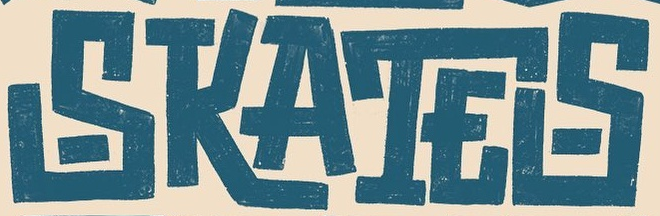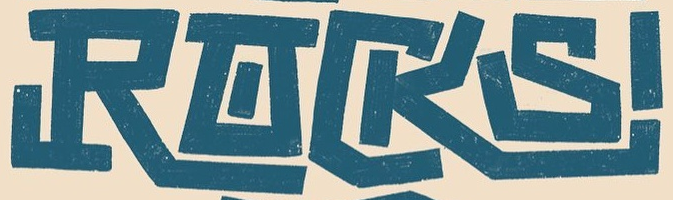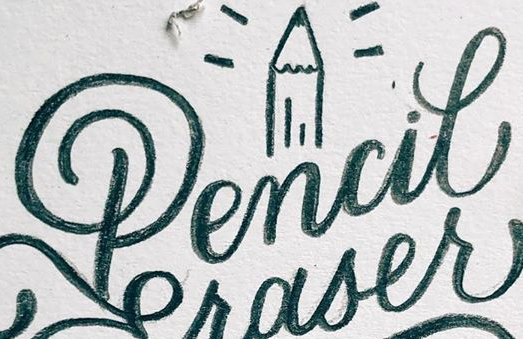What words can you see in these images in sequence, separated by a semicolon? SKATES; RACKS; Pencil 